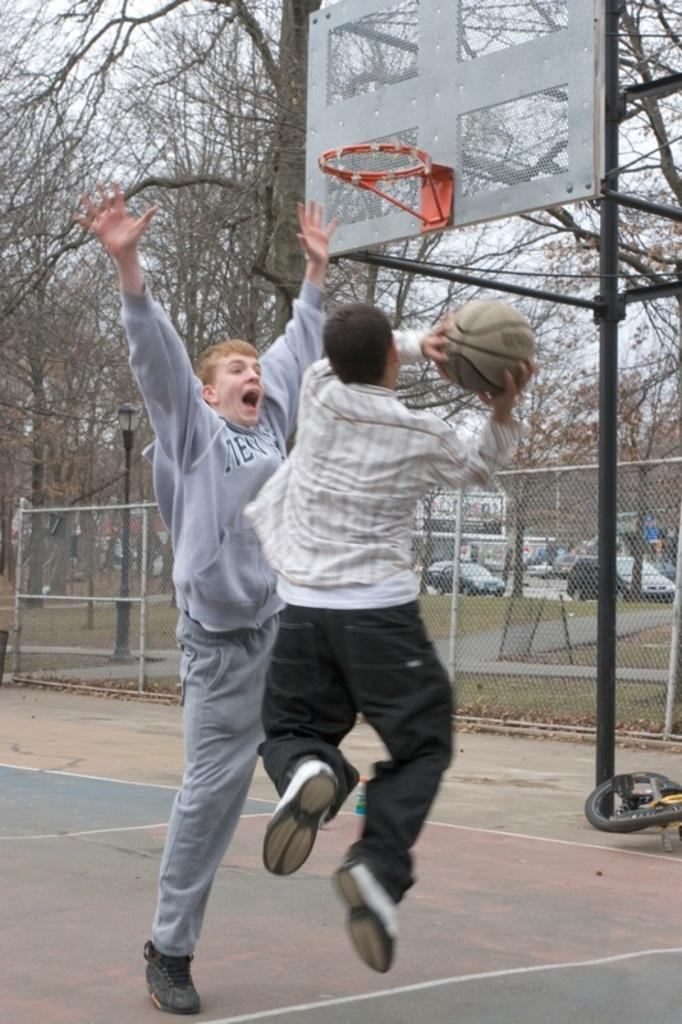How many people are in the image? There are two boys in the image. What activity are the boys engaged in? The boys are playing basketball. What can be seen in the background of the image? There are trees and cars in the background of the image. What type of record is being played in the background of the image? There is no record being played in the image; it features two boys playing basketball with trees and cars in the background. 